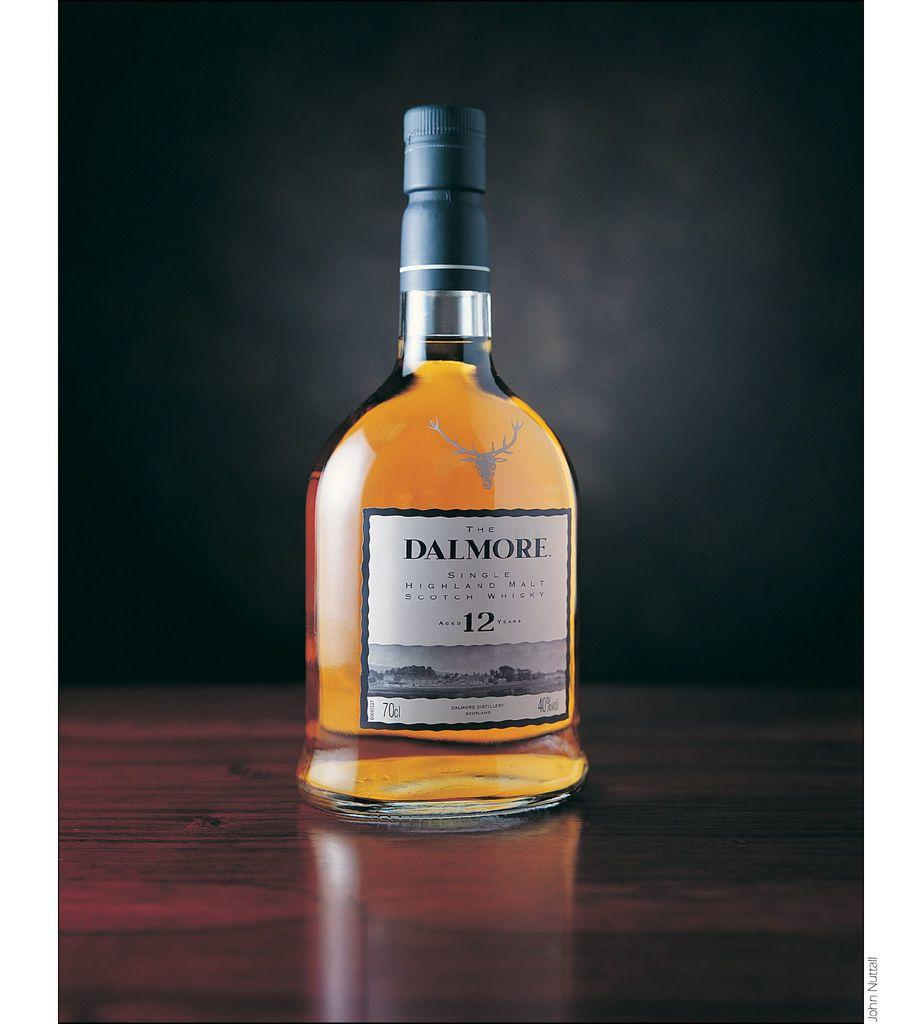<image>
Provide a brief description of the given image. An unopened bottle of Dalmore 12 on a wooden table. 